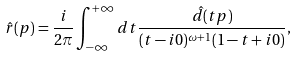<formula> <loc_0><loc_0><loc_500><loc_500>\hat { r } ( p ) = \frac { i } { 2 \pi } \int _ { - \infty } ^ { + \infty } d t \frac { \hat { d } ( t p ) } { ( t - i 0 ) ^ { \omega + 1 } ( 1 - t + i 0 ) } ,</formula> 